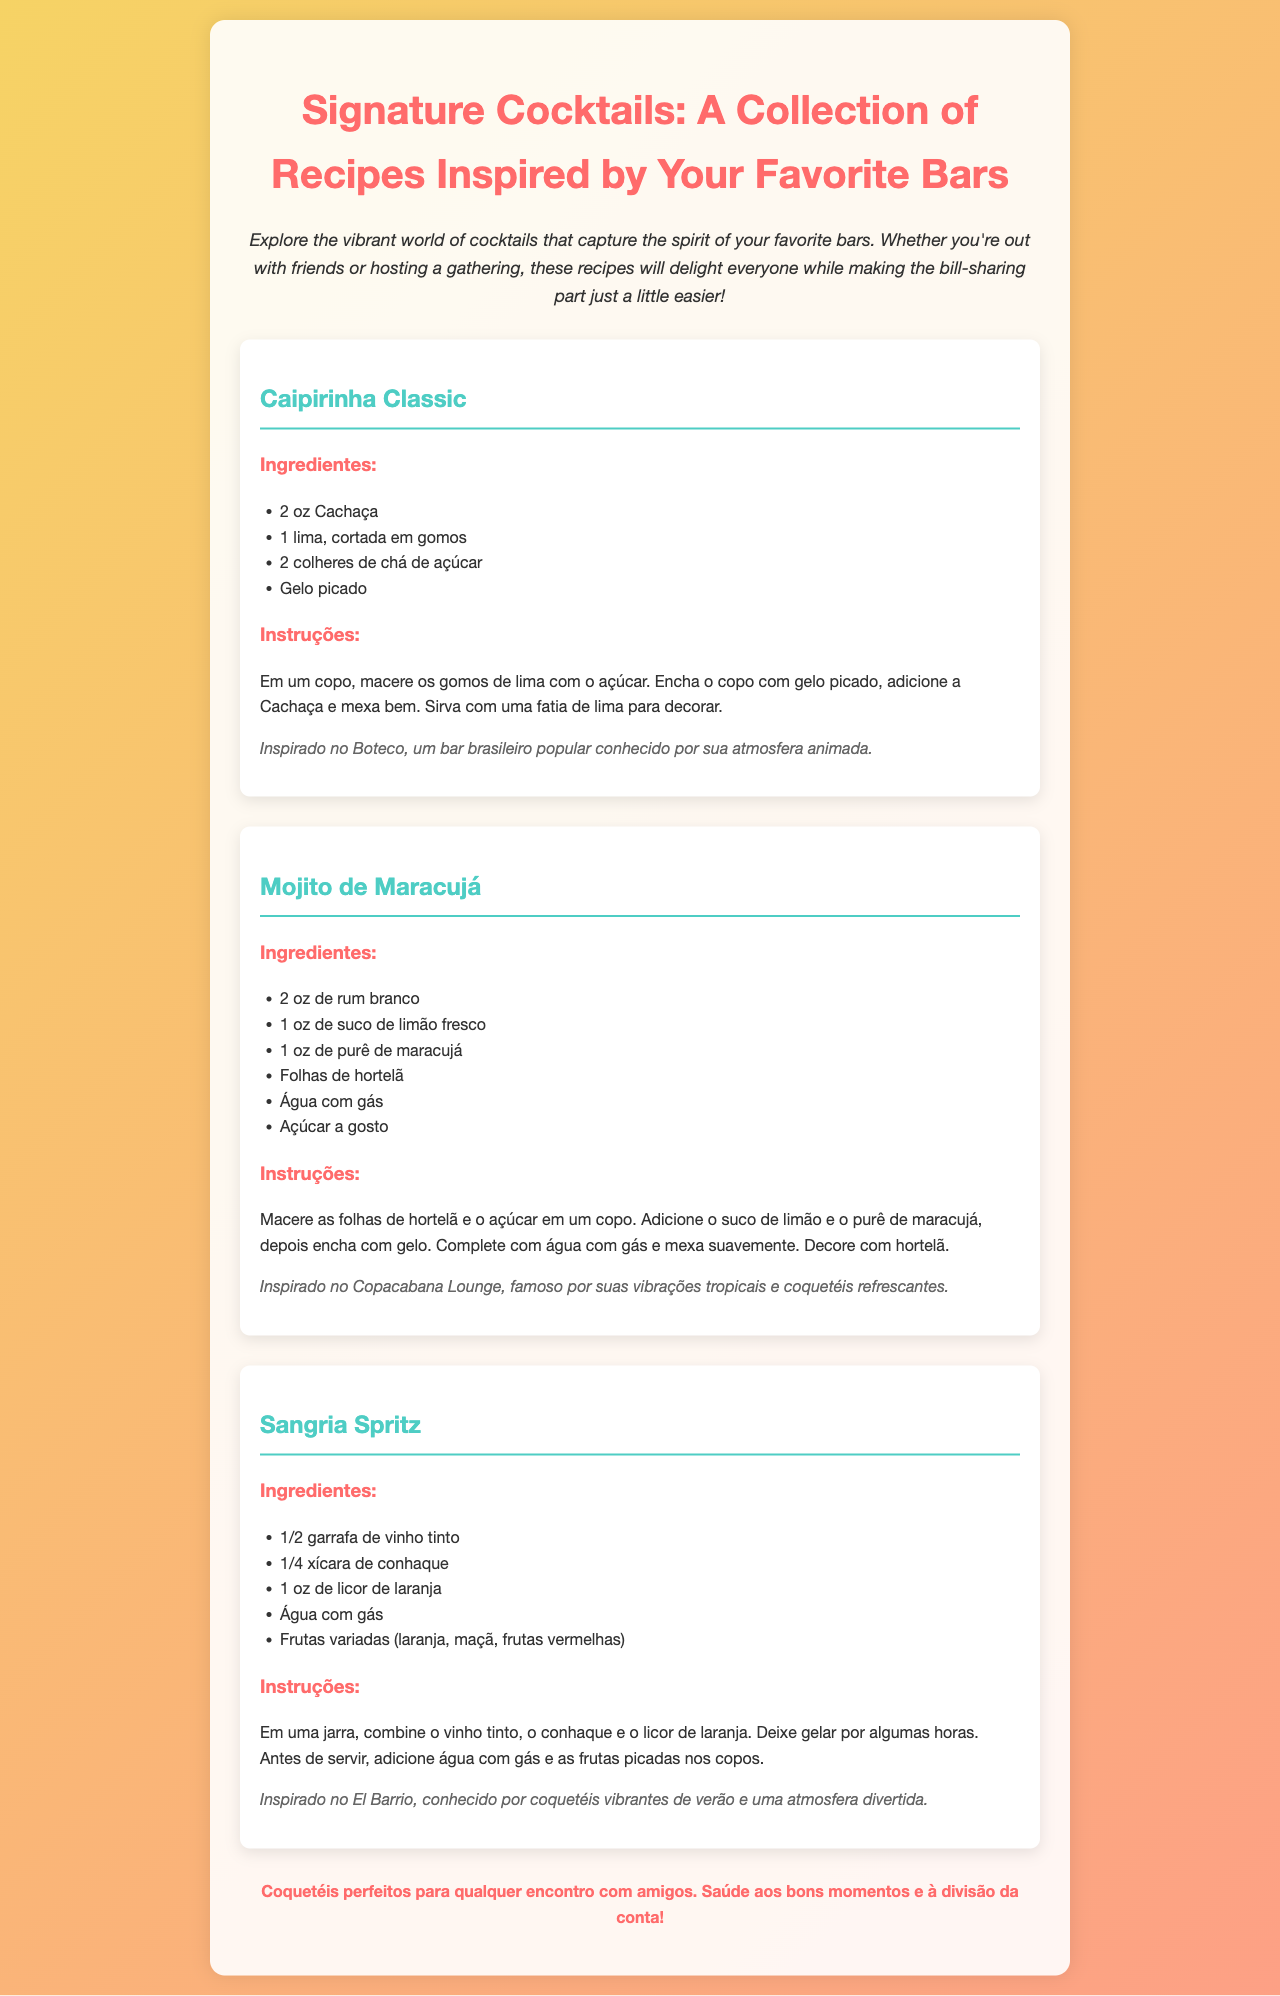Qual é o nome do coquetel inspirado no Boteco? O coquetel inspirado no Boteco é a Caipirinha Classic, conforme mencionado no texto.
Answer: Caipirinha Classic Quantos ingredientes são necessários para fazer o Mojito de Maracujá? O documento lista seis ingredientes necessários para o Mojito de Maracujá.
Answer: 6 Qual é o tipo de vinho utilizado na Sangria Spritz? O documento especifica que é usado vinho tinto para a Sangria Spritz.
Answer: Vinho tinto Qual é a atmosfera do Copacabana Lounge? A atmosfera do Copacabana Lounge é descrita como famosa por suas vibrações tropicais.
Answer: Vibrações tropicais Quais frutas são mencionadas na receita da Sangria Spritz? O documento enumera laranja, maçã e frutas vermelhas como as frutas usadas na Sangria Spritz.
Answer: Laranja, maçã, frutas vermelhas Qual é a bebida base da Caipirinha Classic? O tipo de bebida base da Caipirinha Classic, de acordo com o documento, é a Cachaça.
Answer: Cachaça Que tipo de documento é este? O tipo de documento é um folheto dedicado a receitas de coquetéis.
Answer: Folheto Quem é o público-alvo sugerido para essas receitas? O público-alvo sugerido para as receitas são amigos que se reúnem para uma socialização e diversão.
Answer: Amigos 